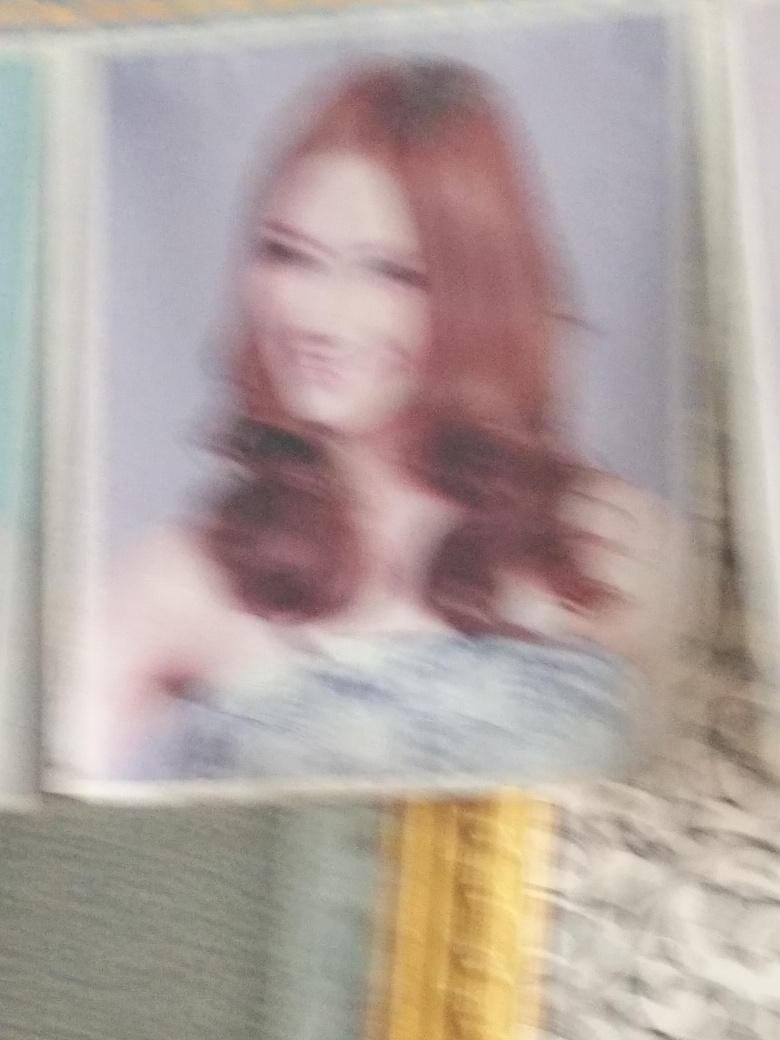What emotions or expressions might the person in the photo be conveying? While it's challenging to interpret emotions or expressions in this blurred image, the slight curvature that appears to be a smile suggests a positive emotion. The subject seems to have a gentle expression, typically associated with warmth or friendliness. However, any detailed analysis of facial expressions would be highly speculative due to the low quality of the image. 